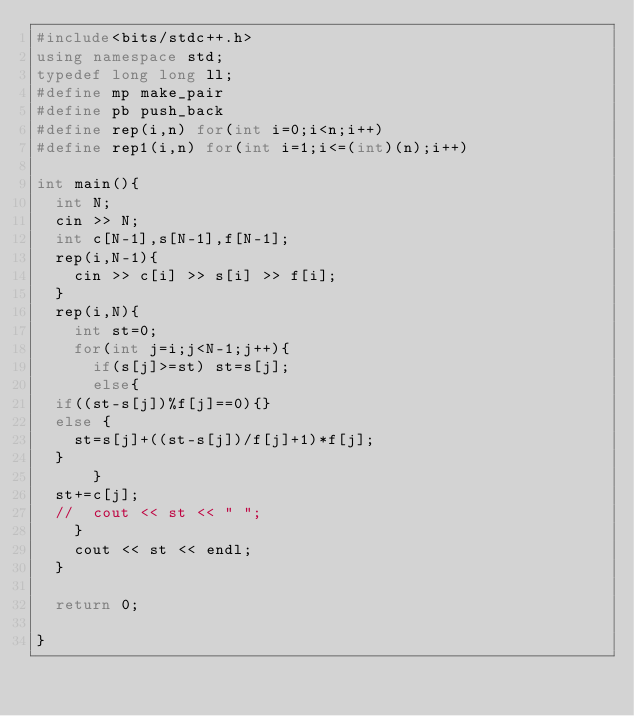<code> <loc_0><loc_0><loc_500><loc_500><_C++_>#include<bits/stdc++.h>
using namespace std;
typedef long long ll;
#define mp make_pair
#define pb push_back
#define rep(i,n) for(int i=0;i<n;i++)
#define rep1(i,n) for(int i=1;i<=(int)(n);i++)

int main(){
  int N;
  cin >> N;
  int c[N-1],s[N-1],f[N-1];
  rep(i,N-1){
    cin >> c[i] >> s[i] >> f[i];
  }
  rep(i,N){
    int st=0;
    for(int j=i;j<N-1;j++){
      if(s[j]>=st) st=s[j];
      else{
	if((st-s[j])%f[j]==0){}
	else {
	  st=s[j]+((st-s[j])/f[j]+1)*f[j];
	}
      }
	st+=c[j];
	//	cout << st << " ";     
    }
    cout << st << endl;
  }

  return 0;

}
</code> 